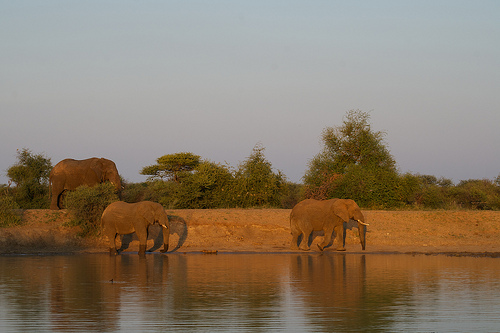How does this image make you feel? The image evokes a sense of tranquility and oneness with nature. The elephants project an aura of majesty and calm, while the serene backdrop and gentle light contribute to an overall feeling of peacefulness. 